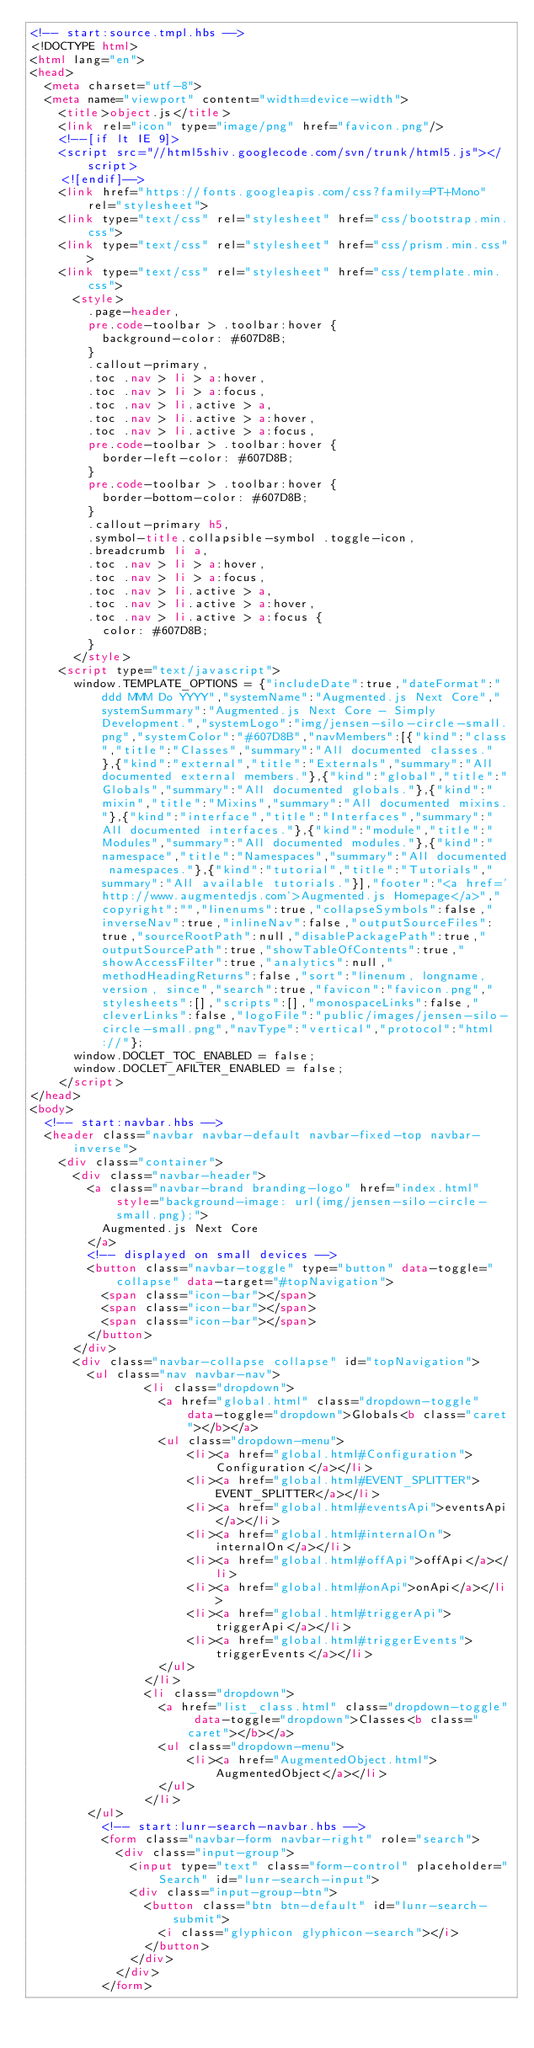Convert code to text. <code><loc_0><loc_0><loc_500><loc_500><_HTML_><!-- start:source.tmpl.hbs -->
<!DOCTYPE html>
<html lang="en">
<head>
	<meta charset="utf-8">
	<meta name="viewport" content="width=device-width">
		<title>object.js</title>
		<link rel="icon" type="image/png" href="favicon.png"/>
		<!--[if lt IE 9]>
		<script src="//html5shiv.googlecode.com/svn/trunk/html5.js"></script>
		<![endif]-->
		<link href="https://fonts.googleapis.com/css?family=PT+Mono" rel="stylesheet">
		<link type="text/css" rel="stylesheet" href="css/bootstrap.min.css">
		<link type="text/css" rel="stylesheet" href="css/prism.min.css">
		<link type="text/css" rel="stylesheet" href="css/template.min.css">
			<style>
				.page-header,
				pre.code-toolbar > .toolbar:hover {
					background-color: #607D8B;
				}
				.callout-primary,
				.toc .nav > li > a:hover,
				.toc .nav > li > a:focus,
				.toc .nav > li.active > a,
				.toc .nav > li.active > a:hover,
				.toc .nav > li.active > a:focus,
				pre.code-toolbar > .toolbar:hover {
					border-left-color: #607D8B;
				}
				pre.code-toolbar > .toolbar:hover {
					border-bottom-color: #607D8B;
				}
				.callout-primary h5,
				.symbol-title.collapsible-symbol .toggle-icon,
				.breadcrumb li a,
				.toc .nav > li > a:hover,
				.toc .nav > li > a:focus,
				.toc .nav > li.active > a,
				.toc .nav > li.active > a:hover,
				.toc .nav > li.active > a:focus {
					color: #607D8B;
				}
			</style>
		<script type="text/javascript">
			window.TEMPLATE_OPTIONS = {"includeDate":true,"dateFormat":"ddd MMM Do YYYY","systemName":"Augmented.js Next Core","systemSummary":"Augmented.js Next Core - Simply Development.","systemLogo":"img/jensen-silo-circle-small.png","systemColor":"#607D8B","navMembers":[{"kind":"class","title":"Classes","summary":"All documented classes."},{"kind":"external","title":"Externals","summary":"All documented external members."},{"kind":"global","title":"Globals","summary":"All documented globals."},{"kind":"mixin","title":"Mixins","summary":"All documented mixins."},{"kind":"interface","title":"Interfaces","summary":"All documented interfaces."},{"kind":"module","title":"Modules","summary":"All documented modules."},{"kind":"namespace","title":"Namespaces","summary":"All documented namespaces."},{"kind":"tutorial","title":"Tutorials","summary":"All available tutorials."}],"footer":"<a href='http://www.augmentedjs.com'>Augmented.js Homepage</a>","copyright":"","linenums":true,"collapseSymbols":false,"inverseNav":true,"inlineNav":false,"outputSourceFiles":true,"sourceRootPath":null,"disablePackagePath":true,"outputSourcePath":true,"showTableOfContents":true,"showAccessFilter":true,"analytics":null,"methodHeadingReturns":false,"sort":"linenum, longname, version, since","search":true,"favicon":"favicon.png","stylesheets":[],"scripts":[],"monospaceLinks":false,"cleverLinks":false,"logoFile":"public/images/jensen-silo-circle-small.png","navType":"vertical","protocol":"html://"};
			window.DOCLET_TOC_ENABLED = false;
			window.DOCLET_AFILTER_ENABLED = false;
		</script>
</head>
<body>
	<!-- start:navbar.hbs -->
	<header class="navbar navbar-default navbar-fixed-top navbar-inverse">
		<div class="container">
			<div class="navbar-header">
				<a class="navbar-brand branding-logo" href="index.html" style="background-image: url(img/jensen-silo-circle-small.png);">
					Augmented.js Next Core
				</a>
				<!-- displayed on small devices -->
				<button class="navbar-toggle" type="button" data-toggle="collapse" data-target="#topNavigation">
					<span class="icon-bar"></span>
					<span class="icon-bar"></span>
					<span class="icon-bar"></span>
				</button>
			</div>
			<div class="navbar-collapse collapse" id="topNavigation">
				<ul class="nav navbar-nav">
								<li class="dropdown">
									<a href="global.html" class="dropdown-toggle" data-toggle="dropdown">Globals<b class="caret"></b></a>
									<ul class="dropdown-menu">
											<li><a href="global.html#Configuration">Configuration</a></li>
											<li><a href="global.html#EVENT_SPLITTER">EVENT_SPLITTER</a></li>
											<li><a href="global.html#eventsApi">eventsApi</a></li>
											<li><a href="global.html#internalOn">internalOn</a></li>
											<li><a href="global.html#offApi">offApi</a></li>
											<li><a href="global.html#onApi">onApi</a></li>
											<li><a href="global.html#triggerApi">triggerApi</a></li>
											<li><a href="global.html#triggerEvents">triggerEvents</a></li>
									</ul>
								</li>
								<li class="dropdown">
									<a href="list_class.html" class="dropdown-toggle" data-toggle="dropdown">Classes<b class="caret"></b></a>
									<ul class="dropdown-menu">
											<li><a href="AugmentedObject.html">AugmentedObject</a></li>
									</ul>
								</li>
				</ul>
					<!-- start:lunr-search-navbar.hbs -->
					<form class="navbar-form navbar-right" role="search">
						<div class="input-group">
							<input type="text" class="form-control" placeholder="Search" id="lunr-search-input">
							<div class="input-group-btn">
								<button class="btn btn-default" id="lunr-search-submit">
									<i class="glyphicon glyphicon-search"></i>
								</button>
							</div>
						</div>
					</form></code> 